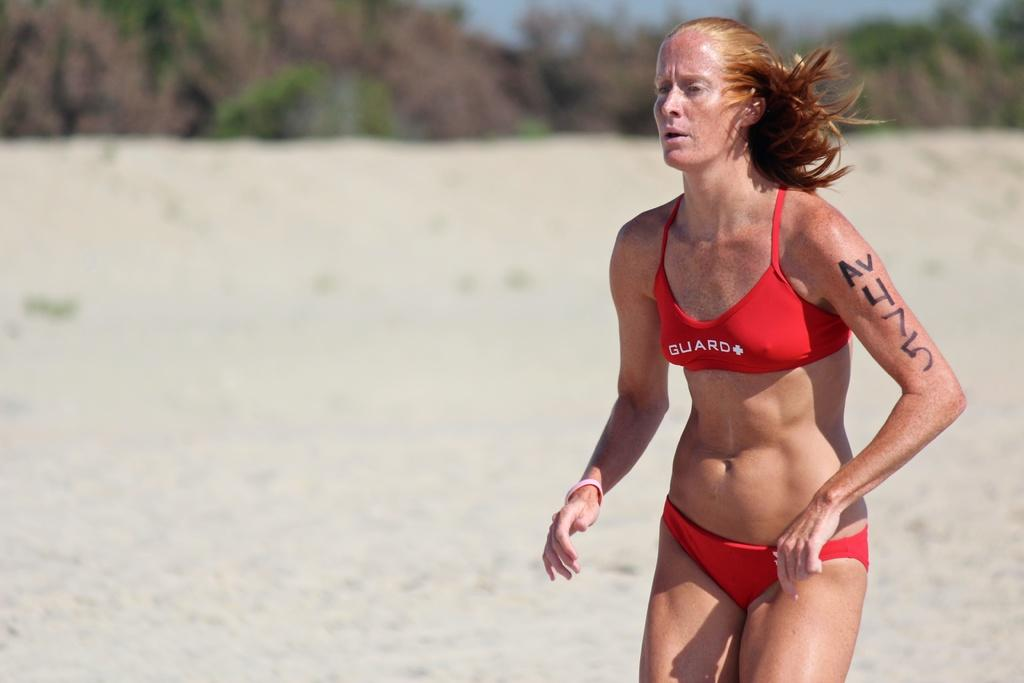Who is the main subject in the image? There is a woman standing in the center of the image. What can be seen in the background of the image? There is sky, trees, and sand visible in the background of the image. What type of bean is growing on the fork in the image? There is no fork or bean present in the image. 